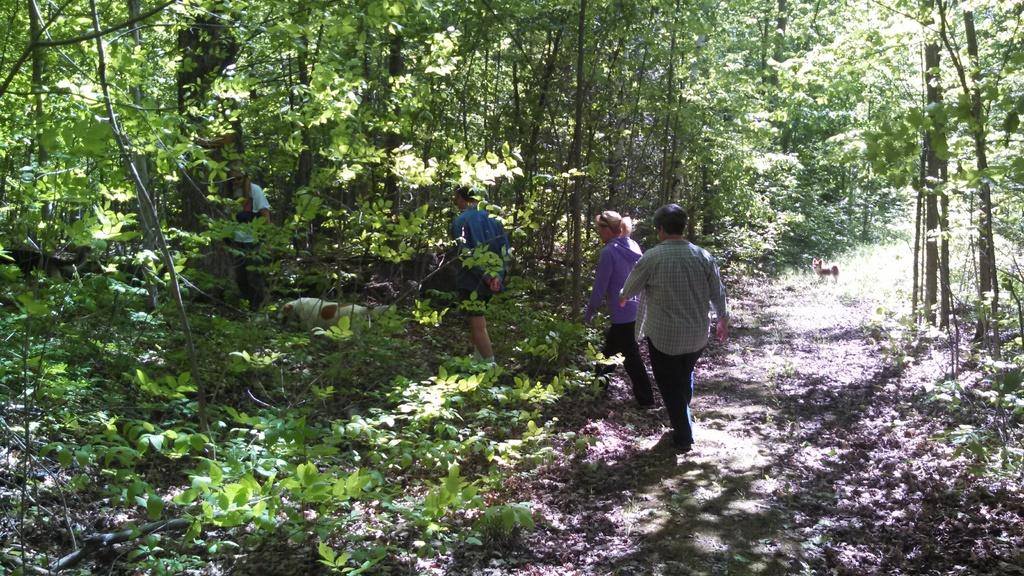What type of natural environment is depicted in the image? There is a forest in the image. What can be found within the forest? There are trees in the forest. Are there any living beings present in the forest? Yes, there are persons and animals in the forest. How many legs can be seen on the trees in the image? Trees do not have legs, so this question cannot be answered. 